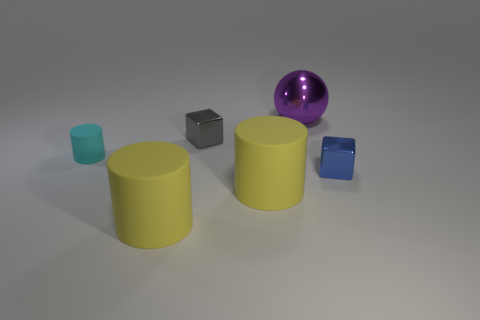Add 2 large yellow matte objects. How many objects exist? 8 Subtract all balls. How many objects are left? 5 Add 1 blue metallic cubes. How many blue metallic cubes are left? 2 Add 3 small gray matte things. How many small gray matte things exist? 3 Subtract 0 blue cylinders. How many objects are left? 6 Subtract all tiny brown objects. Subtract all small blue shiny cubes. How many objects are left? 5 